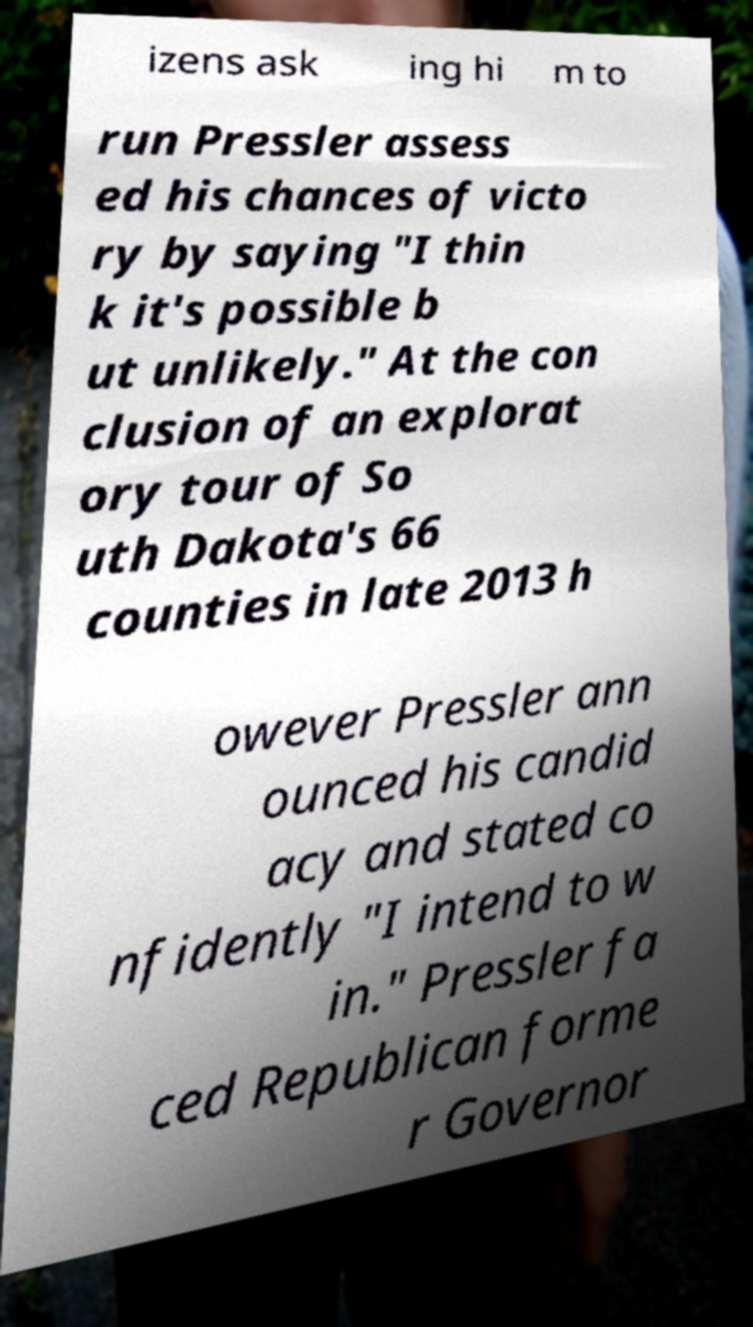There's text embedded in this image that I need extracted. Can you transcribe it verbatim? izens ask ing hi m to run Pressler assess ed his chances of victo ry by saying "I thin k it's possible b ut unlikely." At the con clusion of an explorat ory tour of So uth Dakota's 66 counties in late 2013 h owever Pressler ann ounced his candid acy and stated co nfidently "I intend to w in." Pressler fa ced Republican forme r Governor 